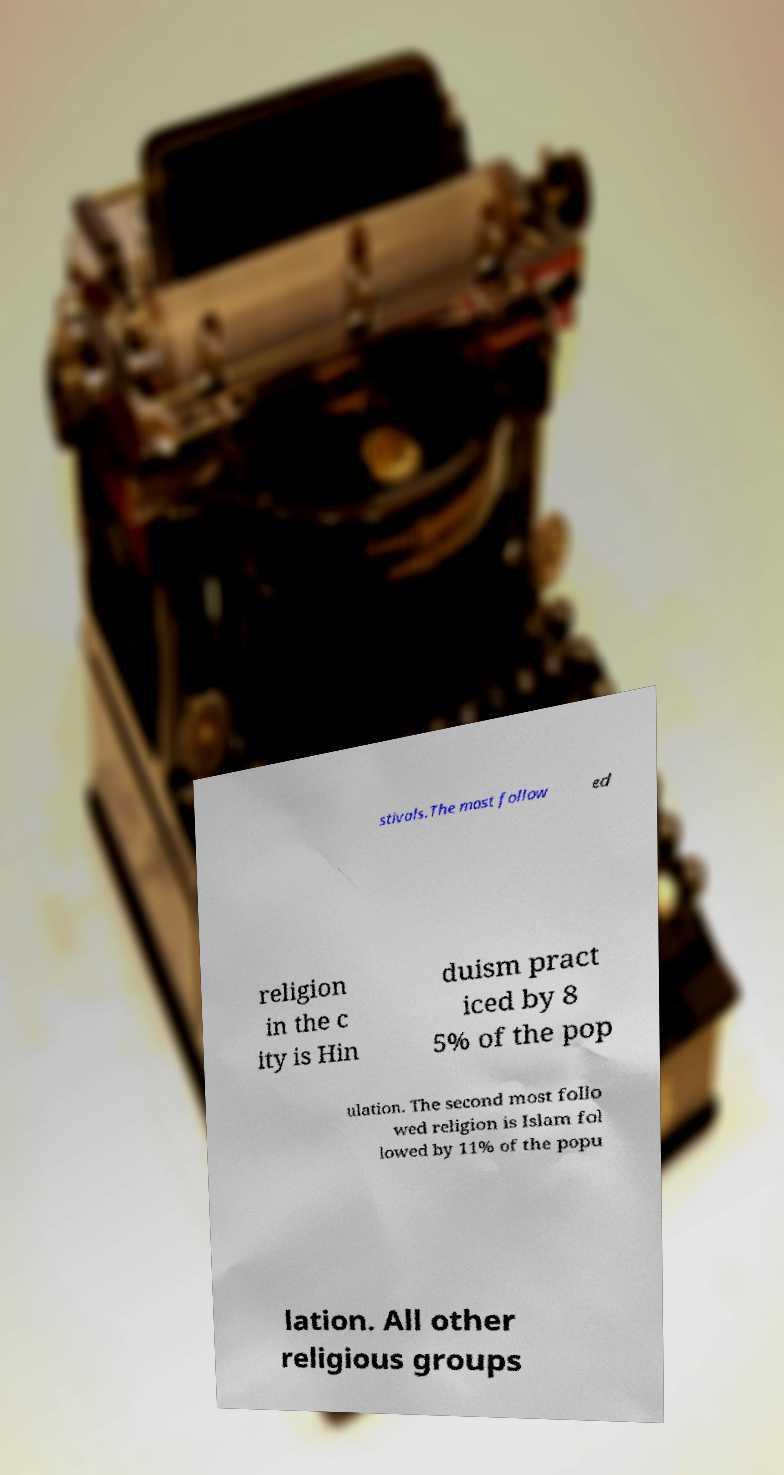I need the written content from this picture converted into text. Can you do that? stivals.The most follow ed religion in the c ity is Hin duism pract iced by 8 5% of the pop ulation. The second most follo wed religion is Islam fol lowed by 11% of the popu lation. All other religious groups 